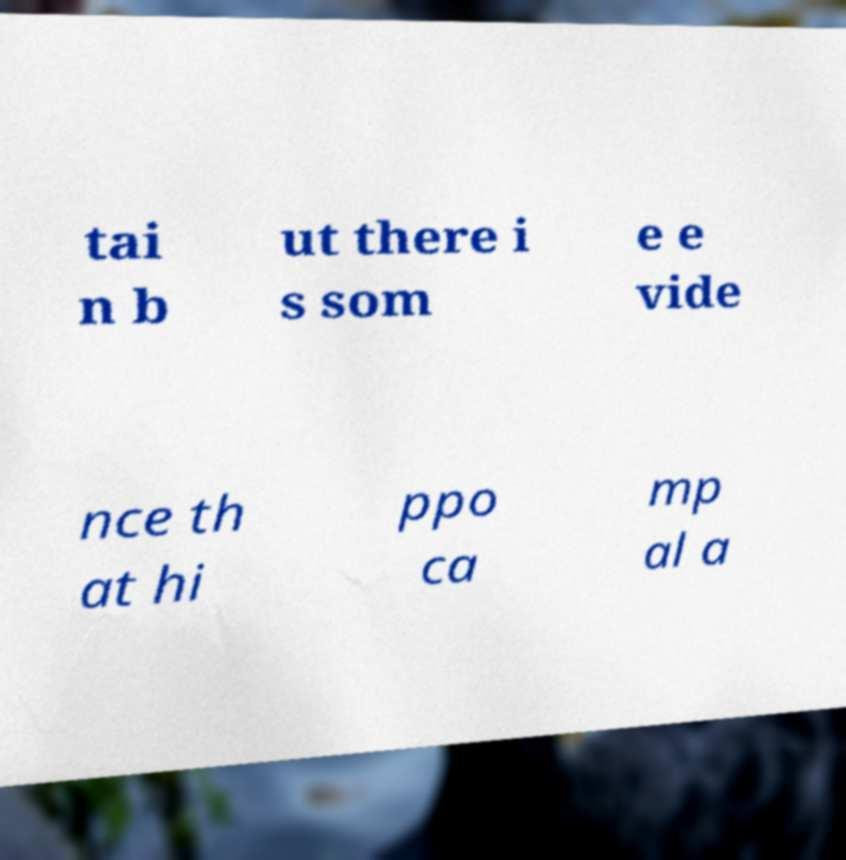Please identify and transcribe the text found in this image. tai n b ut there i s som e e vide nce th at hi ppo ca mp al a 